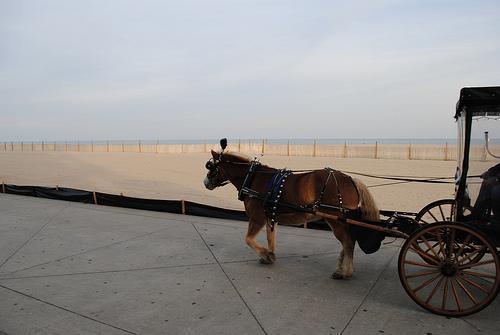How many horses are in this picture?
Give a very brief answer. 1. How many carriages are in this photograph?
Give a very brief answer. 1. How many beaches are in this image?
Give a very brief answer. 1. 